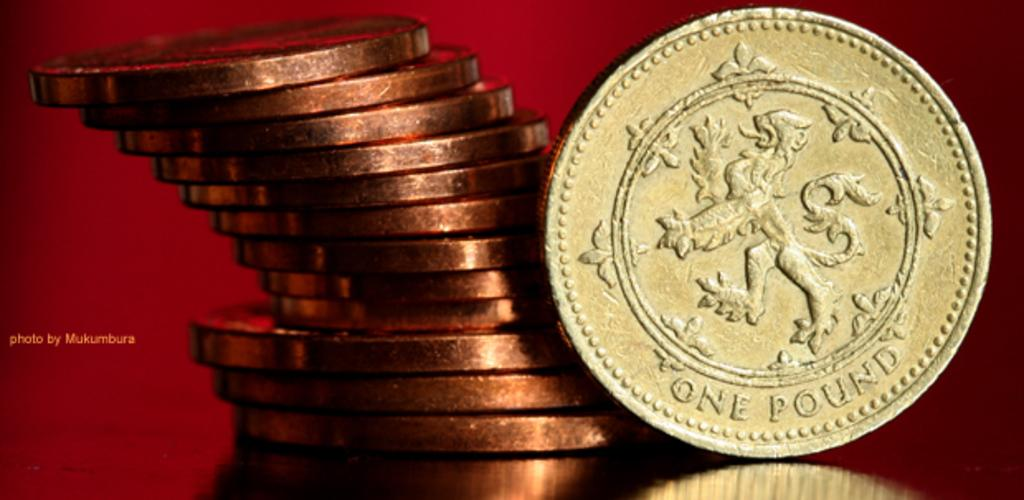<image>
Write a terse but informative summary of the picture. A stack of bronze coins with a gold one pound coin at the front. 